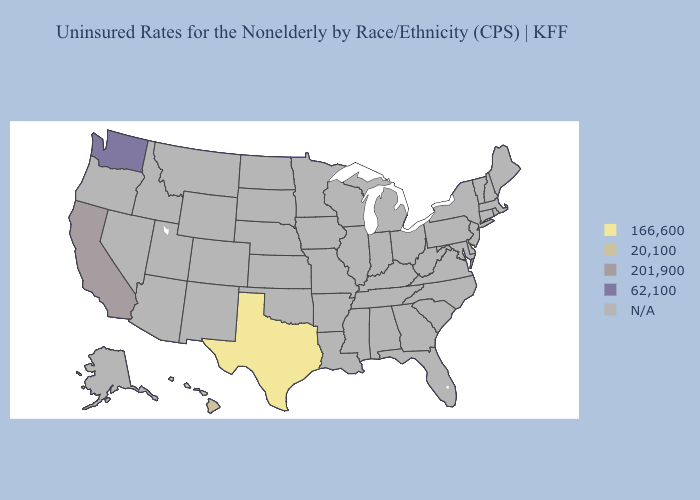What is the lowest value in the South?
Write a very short answer. 166,600. Name the states that have a value in the range 62,100?
Concise answer only. Washington. Does Texas have the lowest value in the USA?
Concise answer only. Yes. What is the value of Pennsylvania?
Be succinct. N/A. What is the lowest value in the USA?
Quick response, please. 166,600. What is the value of Wyoming?
Quick response, please. N/A. Name the states that have a value in the range 20,100?
Answer briefly. Hawaii. Name the states that have a value in the range 62,100?
Be succinct. Washington. Name the states that have a value in the range 62,100?
Concise answer only. Washington. What is the value of Louisiana?
Concise answer only. N/A. Name the states that have a value in the range 201,900?
Quick response, please. California. What is the value of Idaho?
Concise answer only. N/A. Name the states that have a value in the range 20,100?
Write a very short answer. Hawaii. 